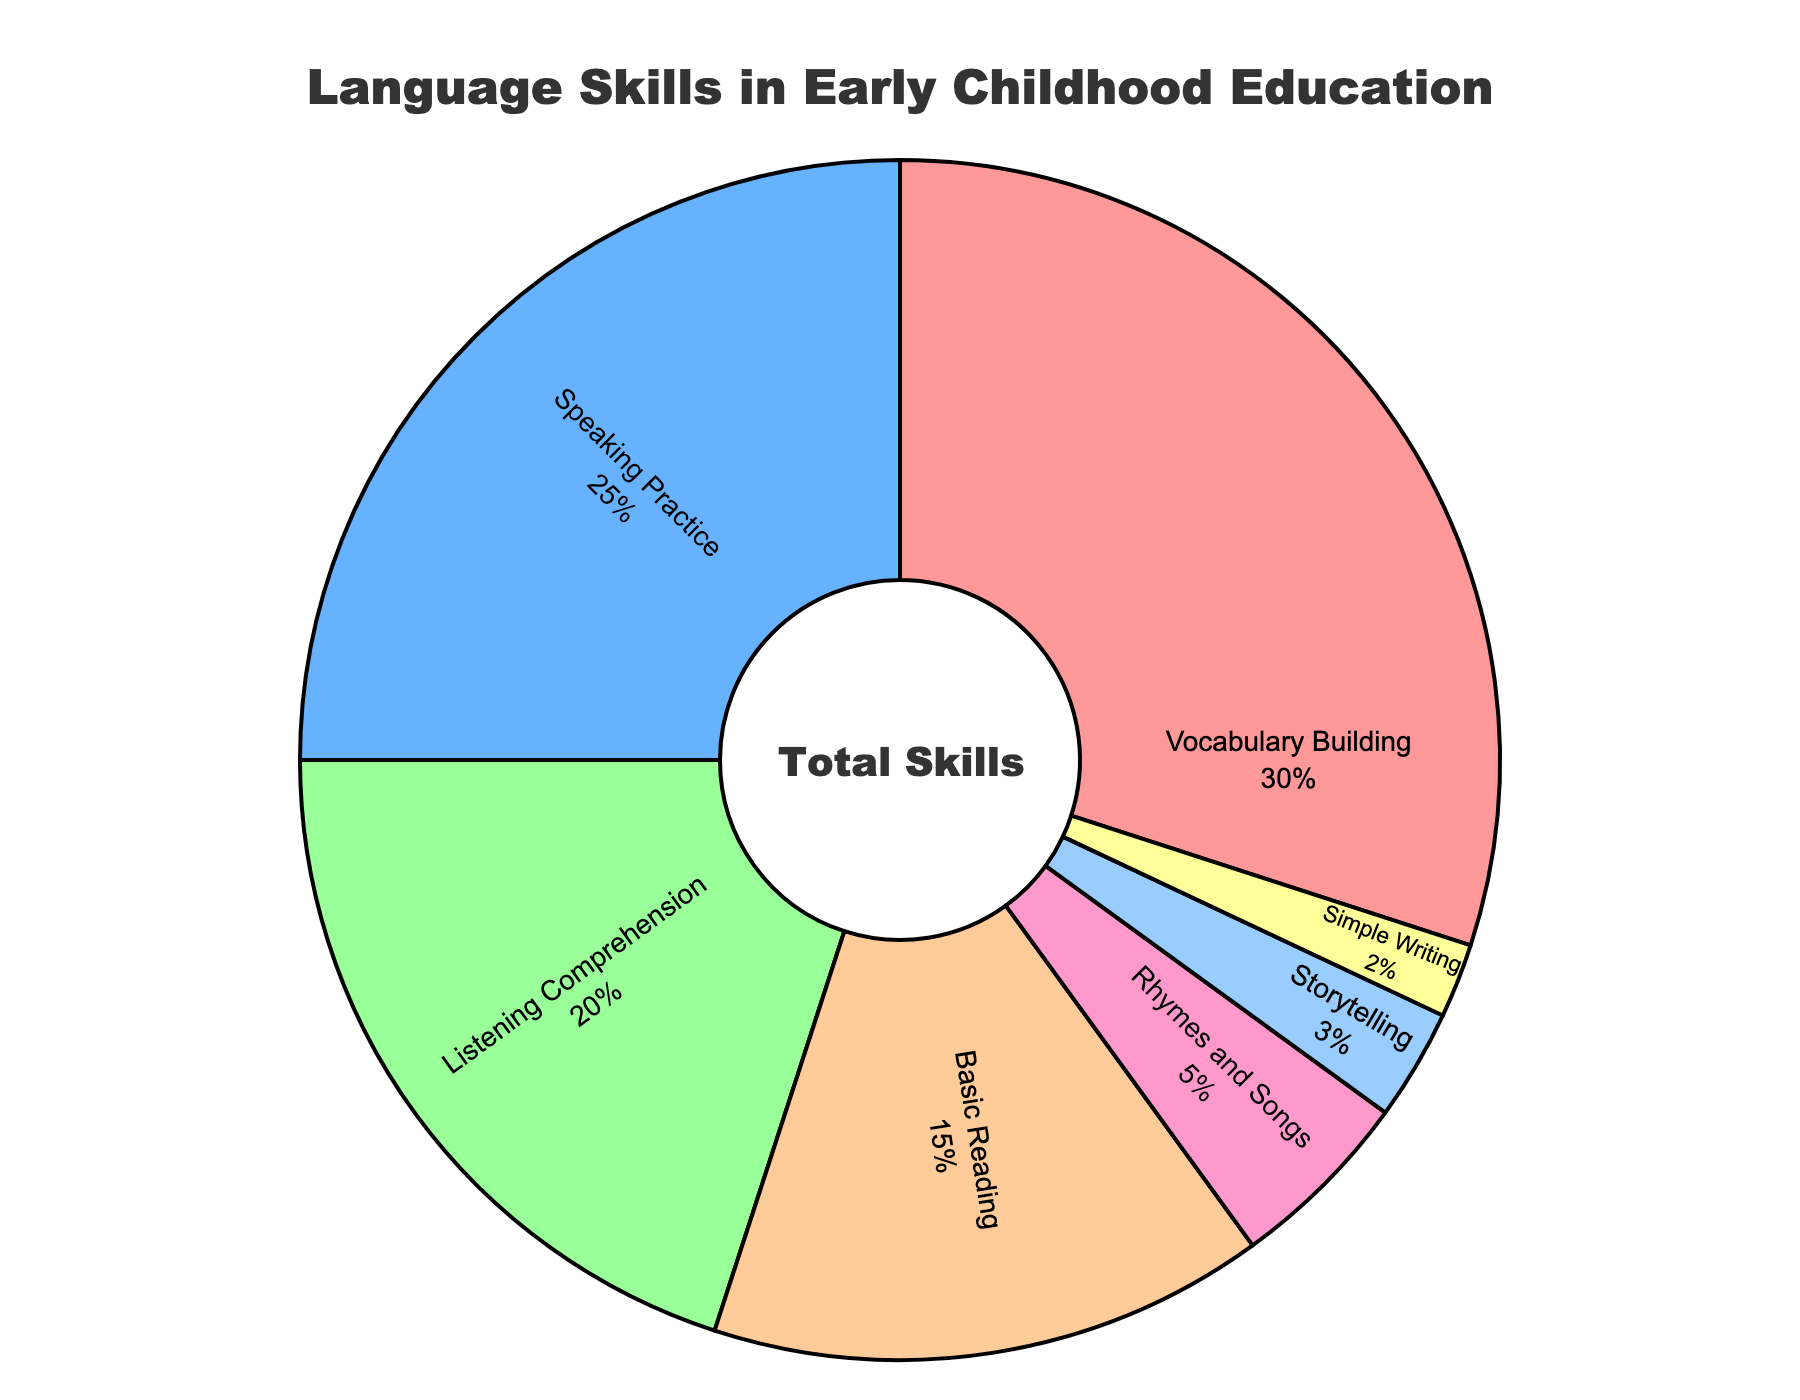Which skill has the highest percentage? By looking at the chart, "Vocabulary Building" occupies the largest section of the pie.
Answer: Vocabulary Building What percentage is allocated to Basic Reading? From the chart, the section labeled "Basic Reading" shows its percentage.
Answer: 15% How much more focus is placed on Vocabulary Building compared to Simple Writing? Vocabulary Building has 30% and Simple Writing has 2%. The difference is found by subtracting these two values (30% - 2%).
Answer: 28% Which skill has a smaller percentage, Rhymes and Songs or Storytelling? Compare the percentages of Rhymes and Songs (5%) and Storytelling (3%) from the chart.
Answer: Storytelling What is the total percentage for Speaking Practice and Listening Comprehension combined? Speaking Practice is 25% and Listening Comprehension is 20%. Add these two percentages (25% + 20%).
Answer: 45% Is the percentage for Speaking Practice greater than that for Basic Reading? Compare the percentages: Speaking Practice (25%) and Basic Reading (15%).
Answer: Yes What percentage is allocated to skills other than Vocabulary Building and Speaking Practice? Subtract the combined percentage of Vocabulary Building (30%) and Speaking Practice (25%) from 100% (100% - 30% - 25%).
Answer: 45% Which section of the pie chart is colored green? By visually identifying the green section, it is labeled "Listening Comprehension".
Answer: Listening Comprehension How does the percentage of Rhymes and Songs compare to that of Simple Writing? Compare the percentages: Rhymes and Songs (5%) and Simple Writing (2%).
Answer: Greater What skill is placed between Speaking Practice and Simple Writing in terms of percentage allocation? From the percentages, identify the skills in descending order: Vocabulary Building (30%), Speaking Practice (25%), Listening Comprehension (20%), Basic Reading (15%), Rhymes and Songs (5%), Storytelling (3%), Simple Writing (2%).
Answer: Storytelling 